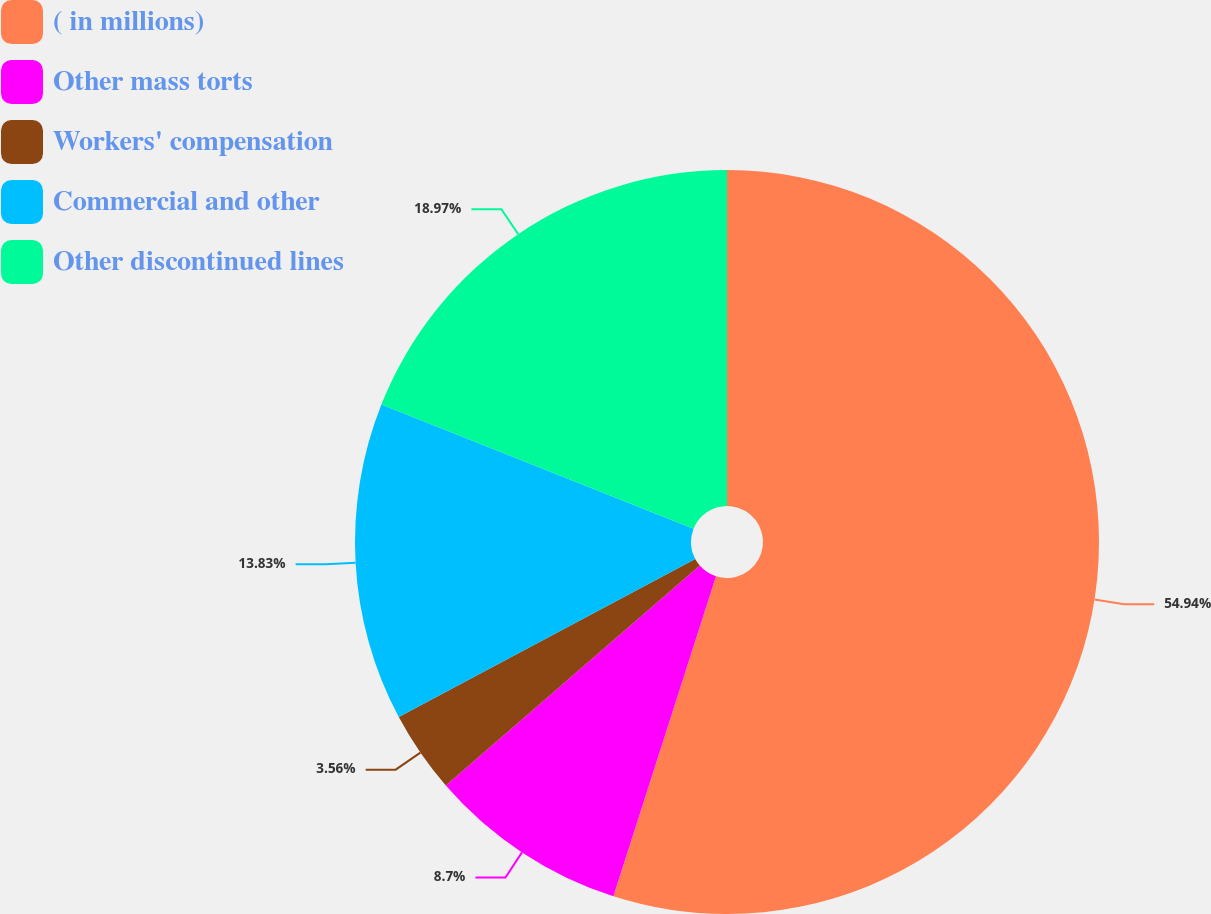Convert chart to OTSL. <chart><loc_0><loc_0><loc_500><loc_500><pie_chart><fcel>( in millions)<fcel>Other mass torts<fcel>Workers' compensation<fcel>Commercial and other<fcel>Other discontinued lines<nl><fcel>54.94%<fcel>8.7%<fcel>3.56%<fcel>13.83%<fcel>18.97%<nl></chart> 